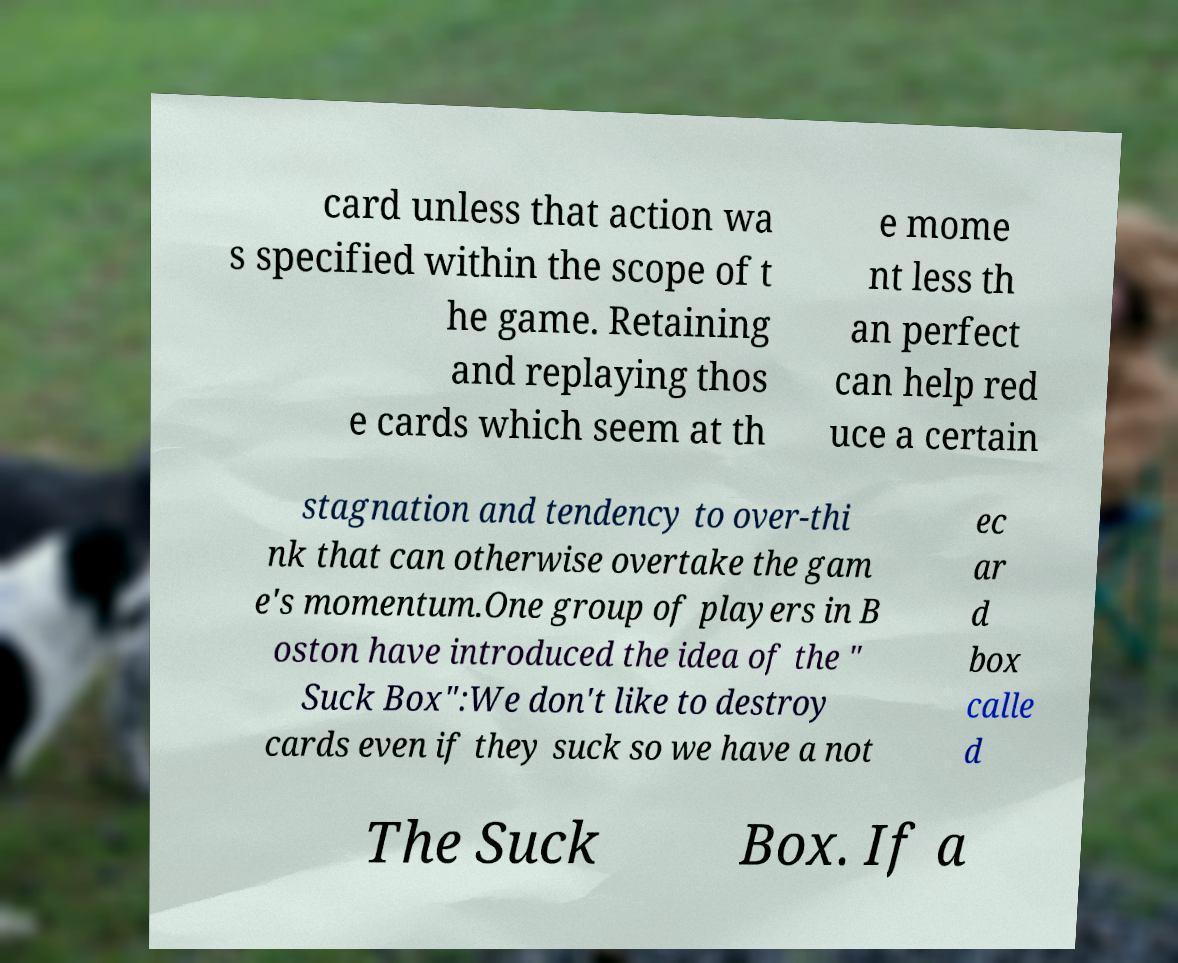Please read and relay the text visible in this image. What does it say? card unless that action wa s specified within the scope of t he game. Retaining and replaying thos e cards which seem at th e mome nt less th an perfect can help red uce a certain stagnation and tendency to over-thi nk that can otherwise overtake the gam e's momentum.One group of players in B oston have introduced the idea of the " Suck Box":We don't like to destroy cards even if they suck so we have a not ec ar d box calle d The Suck Box. If a 